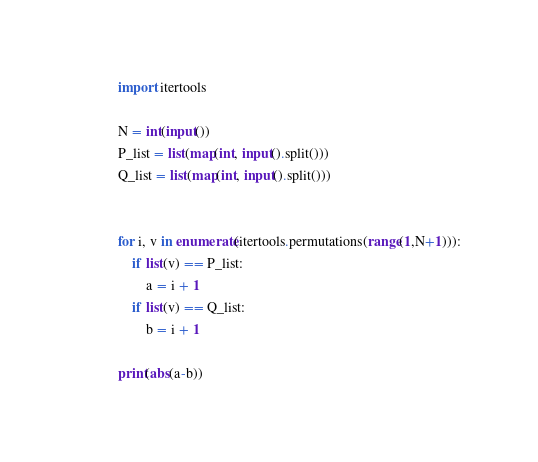Convert code to text. <code><loc_0><loc_0><loc_500><loc_500><_Python_>import itertools

N = int(input())
P_list = list(map(int, input().split()))
Q_list = list(map(int, input().split()))


for i, v in enumerate(itertools.permutations(range(1,N+1))):
    if list(v) == P_list:
        a = i + 1
    if list(v) == Q_list:
        b = i + 1

print(abs(a-b))</code> 